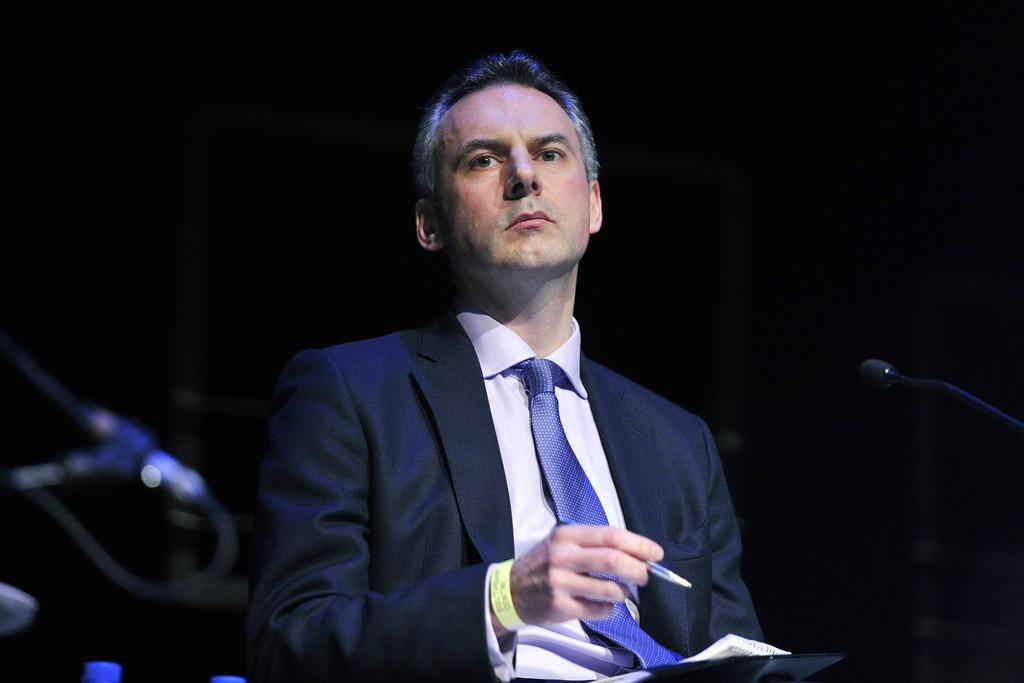What is the person in the image wearing? The person in the image is wearing a suit. What is the person holding in the image? The person is holding a pen. What is the person sitting on in the image? The person is sitting on a chair. What objects can be seen on the table in the image? There are bottles on a table in the image. What device is present in the image for amplifying sound? There is a microphone (mic) in the image. What is the color of the background in the image? The background is dark in color. What type of argument is the person in the image having with the force? There is no argument or force present in the image; it only features a person in a suit holding a pen, sitting on a chair, with bottles on a table and a microphone nearby, against a dark background. 